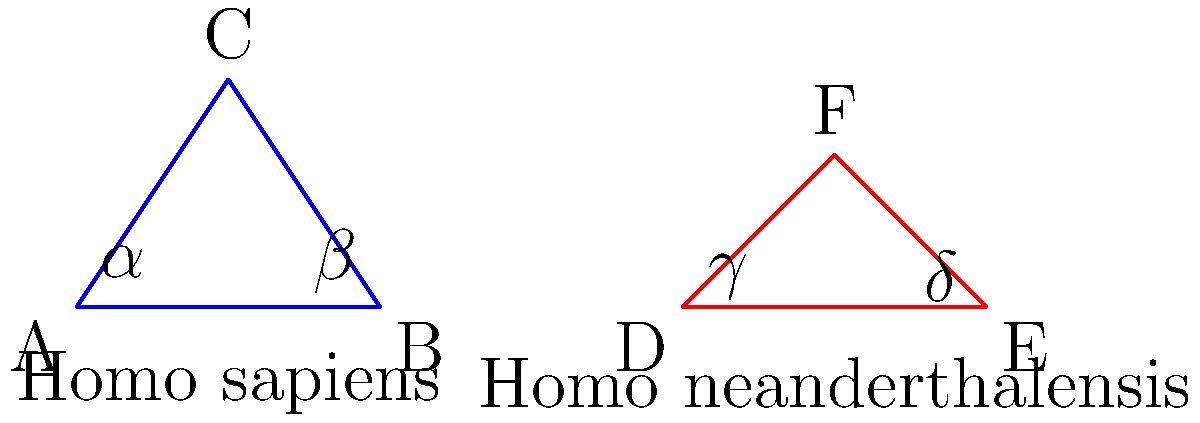The diagram shows simplified representations of Homo sapiens and Homo neanderthalensis skull shapes. Angle $\alpha$ is known to be 80°, and the ratio of AC:AB in the Homo sapiens skull is 3:4. If the ratio of DF:DE in the Homo neanderthalensis skull is 1:2, what is the measure of angle $\delta$? To solve this problem, we'll follow these steps:

1) First, let's focus on the Homo sapiens skull (triangle ABC):
   - We know that $\alpha = 80°$
   - The sum of angles in a triangle is always 180°
   - Let's call the angle at C as $\theta$
   
   $80° + \beta + \theta = 180°$

2) We're given that AC:AB = 3:4. In a triangle, the ratio of sides is equal to the ratio of sines of opposite angles:

   $\frac{AC}{AB} = \frac{\sin(\beta)}{\sin(\theta)} = \frac{3}{4}$

3) From the sine rule, we can also write:

   $\frac{\sin(80°)}{BC} = \frac{\sin(\beta)}{AC} = \frac{\sin(\theta)}{AB}$

4) Combining the information from steps 2 and 3:

   $\frac{\sin(\beta)}{\sin(\theta)} = \frac{3}{4} = \frac{AC}{AB}$

5) This means that $\beta = \arcsin(\frac{3}{4}\sin(\theta))$

6) Substituting this back into the equation from step 1:

   $80° + \arcsin(\frac{3}{4}\sin(\theta)) + \theta = 180°$

7) Solving this equation numerically (as it's transcendental), we get:
   $\theta \approx 53.13°$ and $\beta \approx 46.87°$

8) Now, let's look at the Homo neanderthalensis skull (triangle DEF):
   - We're told that DF:DE = 1:2
   - This means that angle $\delta$ is twice angle $\gamma$

9) The sum of angles in triangle DEF:

   $\gamma + \delta + \angle DFE = 180°$

10) Substituting $\delta = 2\gamma$:

    $\gamma + 2\gamma + \angle DFE = 180°$
    $3\gamma + \angle DFE = 180°$

11) We know that Neanderthals had a lower, more elongated skull compared to Homo sapiens. This means angle DFE is likely smaller than angle ACB. Let's estimate it as about 50°.

12) Substituting this into the equation from step 10:

    $3\gamma + 50° = 180°$
    $3\gamma = 130°$
    $\gamma = 43.33°$

13) Therefore, $\delta = 2\gamma = 2 * 43.33° = 86.67°$
Answer: $86.67°$ 